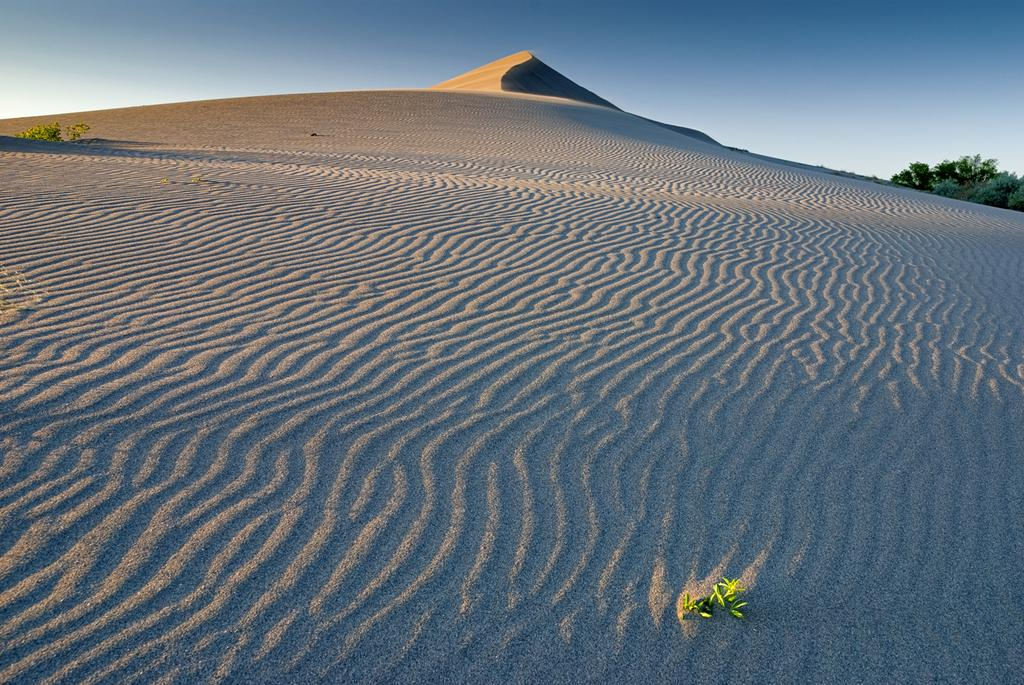What type of environment is shown in the image? The image depicts a desert. What can be seen on the right side of the image? There are trees on the right side of the image. What type of station can be seen in the image? There is no station present in the image; it depicts a desert with trees on the right side. What thrilling activity is taking place in the image? The image does not depict any thrilling activities; it shows a desert with trees. 